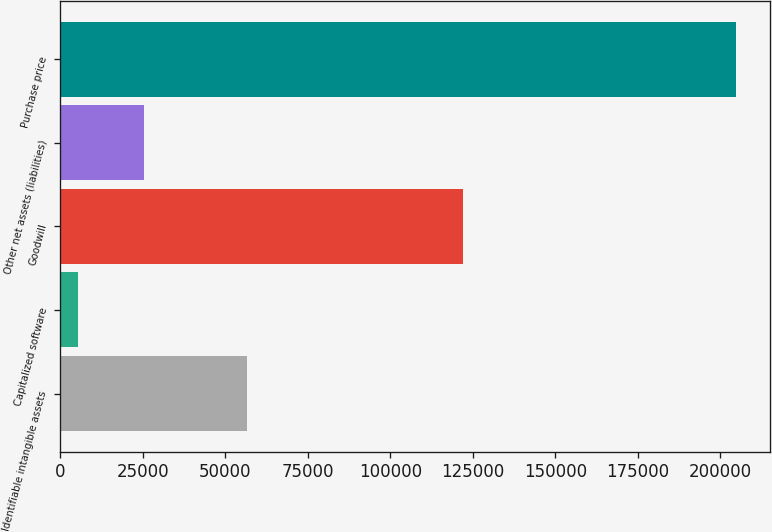Convert chart to OTSL. <chart><loc_0><loc_0><loc_500><loc_500><bar_chart><fcel>Identifiable intangible assets<fcel>Capitalized software<fcel>Goodwill<fcel>Other net assets (liabilities)<fcel>Purchase price<nl><fcel>56610<fcel>5275<fcel>122003<fcel>25224.3<fcel>204768<nl></chart> 